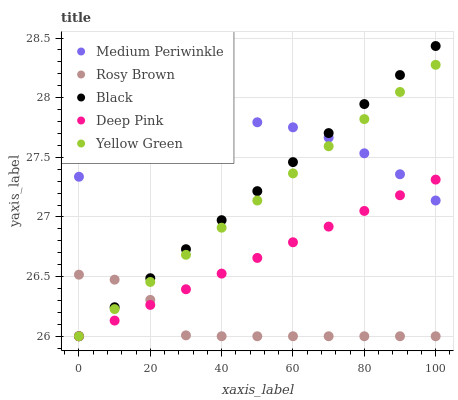Does Rosy Brown have the minimum area under the curve?
Answer yes or no. Yes. Does Medium Periwinkle have the maximum area under the curve?
Answer yes or no. Yes. Does Medium Periwinkle have the minimum area under the curve?
Answer yes or no. No. Does Rosy Brown have the maximum area under the curve?
Answer yes or no. No. Is Yellow Green the smoothest?
Answer yes or no. Yes. Is Rosy Brown the roughest?
Answer yes or no. Yes. Is Medium Periwinkle the smoothest?
Answer yes or no. No. Is Medium Periwinkle the roughest?
Answer yes or no. No. Does Black have the lowest value?
Answer yes or no. Yes. Does Medium Periwinkle have the lowest value?
Answer yes or no. No. Does Black have the highest value?
Answer yes or no. Yes. Does Medium Periwinkle have the highest value?
Answer yes or no. No. Is Rosy Brown less than Medium Periwinkle?
Answer yes or no. Yes. Is Medium Periwinkle greater than Rosy Brown?
Answer yes or no. Yes. Does Deep Pink intersect Medium Periwinkle?
Answer yes or no. Yes. Is Deep Pink less than Medium Periwinkle?
Answer yes or no. No. Is Deep Pink greater than Medium Periwinkle?
Answer yes or no. No. Does Rosy Brown intersect Medium Periwinkle?
Answer yes or no. No. 